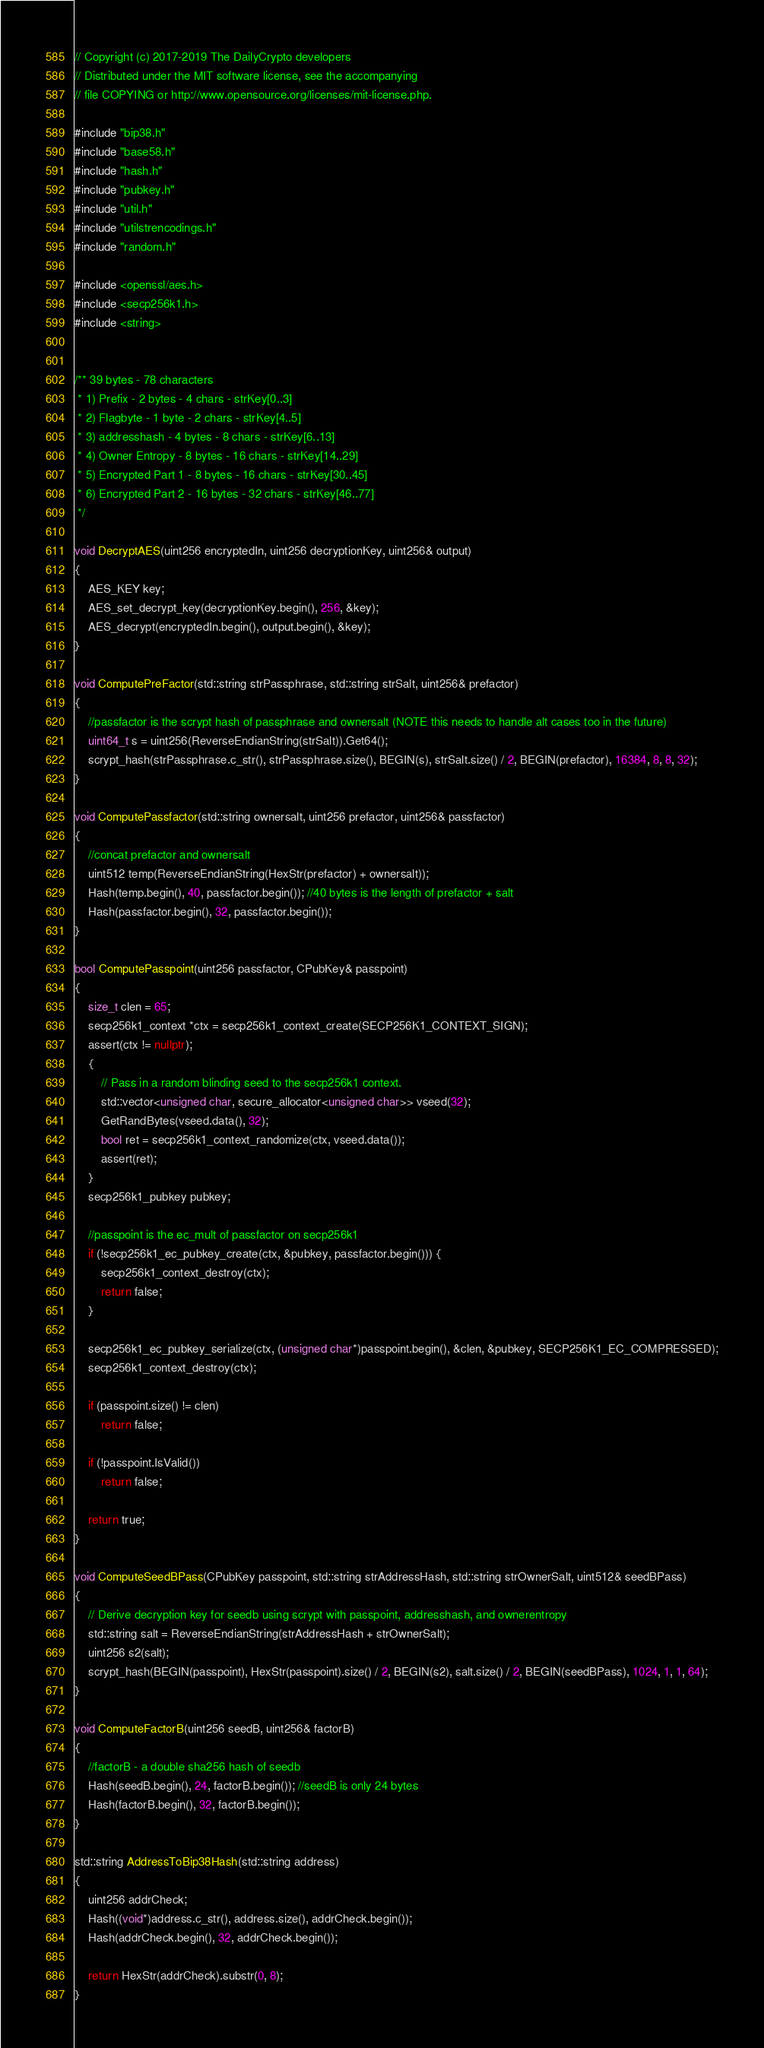<code> <loc_0><loc_0><loc_500><loc_500><_C++_>// Copyright (c) 2017-2019 The DailyCrypto developers
// Distributed under the MIT software license, see the accompanying
// file COPYING or http://www.opensource.org/licenses/mit-license.php.

#include "bip38.h"
#include "base58.h"
#include "hash.h"
#include "pubkey.h"
#include "util.h"
#include "utilstrencodings.h"
#include "random.h"

#include <openssl/aes.h>
#include <secp256k1.h>
#include <string>


/** 39 bytes - 78 characters
 * 1) Prefix - 2 bytes - 4 chars - strKey[0..3]
 * 2) Flagbyte - 1 byte - 2 chars - strKey[4..5]
 * 3) addresshash - 4 bytes - 8 chars - strKey[6..13]
 * 4) Owner Entropy - 8 bytes - 16 chars - strKey[14..29]
 * 5) Encrypted Part 1 - 8 bytes - 16 chars - strKey[30..45]
 * 6) Encrypted Part 2 - 16 bytes - 32 chars - strKey[46..77]
 */

void DecryptAES(uint256 encryptedIn, uint256 decryptionKey, uint256& output)
{
    AES_KEY key;
    AES_set_decrypt_key(decryptionKey.begin(), 256, &key);
    AES_decrypt(encryptedIn.begin(), output.begin(), &key);
}

void ComputePreFactor(std::string strPassphrase, std::string strSalt, uint256& prefactor)
{
    //passfactor is the scrypt hash of passphrase and ownersalt (NOTE this needs to handle alt cases too in the future)
    uint64_t s = uint256(ReverseEndianString(strSalt)).Get64();
    scrypt_hash(strPassphrase.c_str(), strPassphrase.size(), BEGIN(s), strSalt.size() / 2, BEGIN(prefactor), 16384, 8, 8, 32);
}

void ComputePassfactor(std::string ownersalt, uint256 prefactor, uint256& passfactor)
{
    //concat prefactor and ownersalt
    uint512 temp(ReverseEndianString(HexStr(prefactor) + ownersalt));
    Hash(temp.begin(), 40, passfactor.begin()); //40 bytes is the length of prefactor + salt
    Hash(passfactor.begin(), 32, passfactor.begin());
}

bool ComputePasspoint(uint256 passfactor, CPubKey& passpoint)
{
    size_t clen = 65;
    secp256k1_context *ctx = secp256k1_context_create(SECP256K1_CONTEXT_SIGN);
    assert(ctx != nullptr);
    {
        // Pass in a random blinding seed to the secp256k1 context.
        std::vector<unsigned char, secure_allocator<unsigned char>> vseed(32);
        GetRandBytes(vseed.data(), 32);
        bool ret = secp256k1_context_randomize(ctx, vseed.data());
        assert(ret);
    }
    secp256k1_pubkey pubkey;

    //passpoint is the ec_mult of passfactor on secp256k1
    if (!secp256k1_ec_pubkey_create(ctx, &pubkey, passfactor.begin())) {
        secp256k1_context_destroy(ctx);
        return false;
    }

    secp256k1_ec_pubkey_serialize(ctx, (unsigned char*)passpoint.begin(), &clen, &pubkey, SECP256K1_EC_COMPRESSED);
    secp256k1_context_destroy(ctx);

    if (passpoint.size() != clen)
        return false;

    if (!passpoint.IsValid())
        return false;

    return true;
}

void ComputeSeedBPass(CPubKey passpoint, std::string strAddressHash, std::string strOwnerSalt, uint512& seedBPass)
{
    // Derive decryption key for seedb using scrypt with passpoint, addresshash, and ownerentropy
    std::string salt = ReverseEndianString(strAddressHash + strOwnerSalt);
    uint256 s2(salt);
    scrypt_hash(BEGIN(passpoint), HexStr(passpoint).size() / 2, BEGIN(s2), salt.size() / 2, BEGIN(seedBPass), 1024, 1, 1, 64);
}

void ComputeFactorB(uint256 seedB, uint256& factorB)
{
    //factorB - a double sha256 hash of seedb
    Hash(seedB.begin(), 24, factorB.begin()); //seedB is only 24 bytes
    Hash(factorB.begin(), 32, factorB.begin());
}

std::string AddressToBip38Hash(std::string address)
{
    uint256 addrCheck;
    Hash((void*)address.c_str(), address.size(), addrCheck.begin());
    Hash(addrCheck.begin(), 32, addrCheck.begin());

    return HexStr(addrCheck).substr(0, 8);
}
</code> 